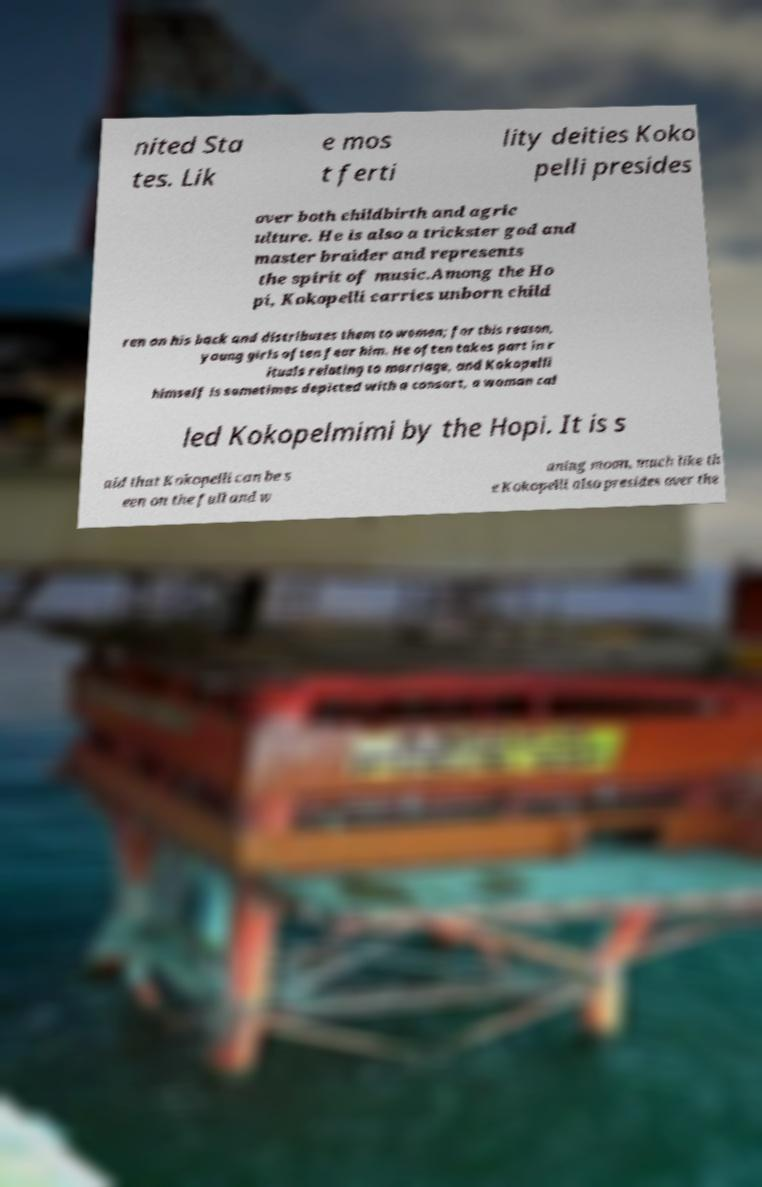Please read and relay the text visible in this image. What does it say? nited Sta tes. Lik e mos t ferti lity deities Koko pelli presides over both childbirth and agric ulture. He is also a trickster god and master braider and represents the spirit of music.Among the Ho pi, Kokopelli carries unborn child ren on his back and distributes them to women; for this reason, young girls often fear him. He often takes part in r ituals relating to marriage, and Kokopelli himself is sometimes depicted with a consort, a woman cal led Kokopelmimi by the Hopi. It is s aid that Kokopelli can be s een on the full and w aning moon, much like th e Kokopelli also presides over the 